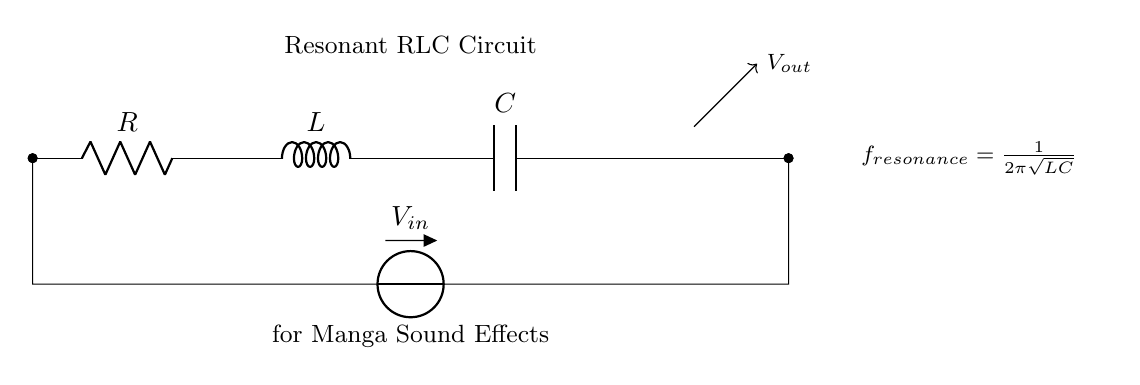What is the primary function of the circuit? The primary function of the circuit is to generate sound effects, as indicated in the label. A resonant RLC circuit is commonly used for sound synthesis in animation studios due to its ability to create specific frequencies.
Answer: sound effects What components are present in this circuit? The circuit consists of a resistor, an inductor, and a capacitor. These components are standard for a resonant RLC circuit and are positioned in series, as seen in the diagram.
Answer: resistor, inductor, capacitor What does the formula in the circuit represent? The formula represents the resonant frequency of the circuit, calculated by the relationship between the inductor and capacitor. It indicates the frequency at which the circuit resonates, producing sound at that frequency.
Answer: f resonance = 1/2π√(LC) What is the purpose of the input voltage, V_in? The input voltage, labeled V_in, provides the necessary electrical energy to the circuit for it to operate and generate the desired sound effects. It is the source that drives the components in the circuit.
Answer: to provide energy How does the resonance frequency change with component values? The resonance frequency is influenced by the values of the inductor and capacitor according to the formula. If the inductance or capacitance increases, the resonance frequency decreases, and vice versa, allowing for tuning of sound characteristics.
Answer: inversely related What type of current flows through this circuit? The circuit typically operates using alternating current, as it is designed for producing oscillatory signals that create sound waves. The behavior of the RLC circuit aligns with this waveform to achieve resonance.
Answer: alternating current What will happen if the resistance is increased? Increasing the resistance generally results in a lower amplitude of the output voltage and may dampen the oscillations. This affects the quality of sound produced, reducing the sharpness and sustain of the resonance.
Answer: output decreases 